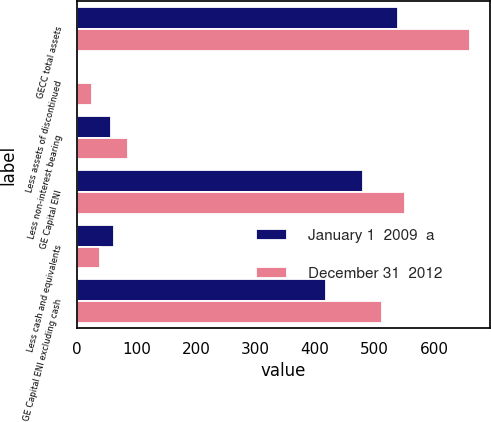<chart> <loc_0><loc_0><loc_500><loc_500><stacked_bar_chart><ecel><fcel>GECC total assets<fcel>Less assets of discontinued<fcel>Less non-interest bearing<fcel>GE Capital ENI<fcel>Less cash and equivalents<fcel>GE Capital ENI excluding cash<nl><fcel>January 1  2009  a<fcel>539.2<fcel>1.1<fcel>57.6<fcel>480.5<fcel>61.9<fcel>418.6<nl><fcel>December 31  2012<fcel>661<fcel>25.1<fcel>85.4<fcel>550.5<fcel>37.7<fcel>512.8<nl></chart> 